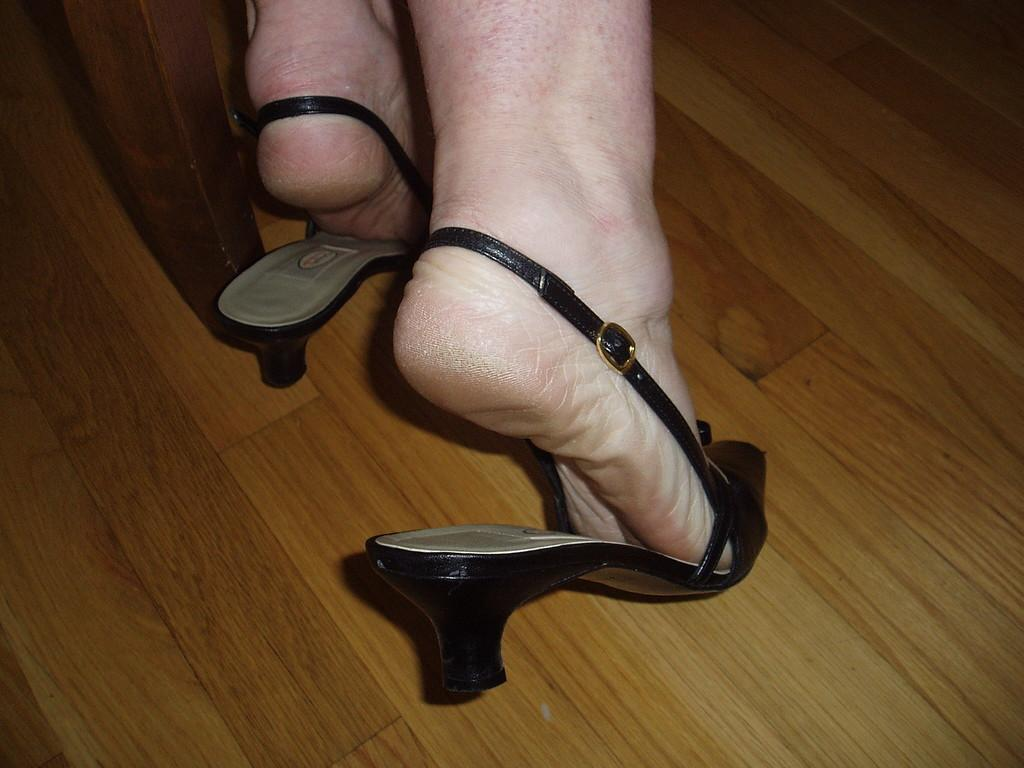What type of footwear is the person wearing in the image? The person is wearing sandals. What part of the person's body is visible in the image? There are legs visible in the image. Where are the legs and sandals located? The legs and sandals are on the floor. What type of business is being conducted in the image? There is no indication of any business being conducted in the image; it only shows legs and sandals on the floor. 